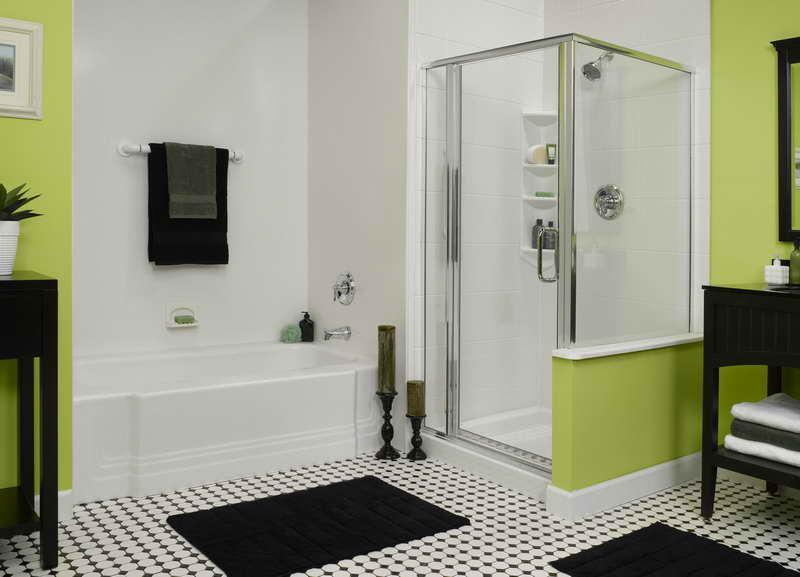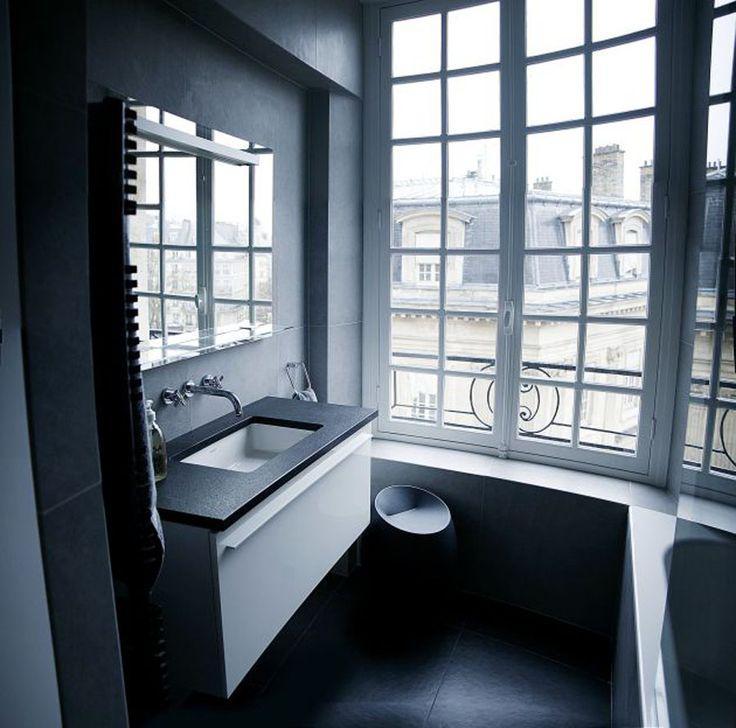The first image is the image on the left, the second image is the image on the right. Examine the images to the left and right. Is the description "In one image, a panel of the shower enclosure has a lower section that is an extension of the bathroom wall and an upper section that is a clear glass window showing the shower head." accurate? Answer yes or no. Yes. The first image is the image on the left, the second image is the image on the right. Examine the images to the left and right. Is the description "An image shows a paned window near a sink with one spout and separate faucet handles." accurate? Answer yes or no. Yes. 